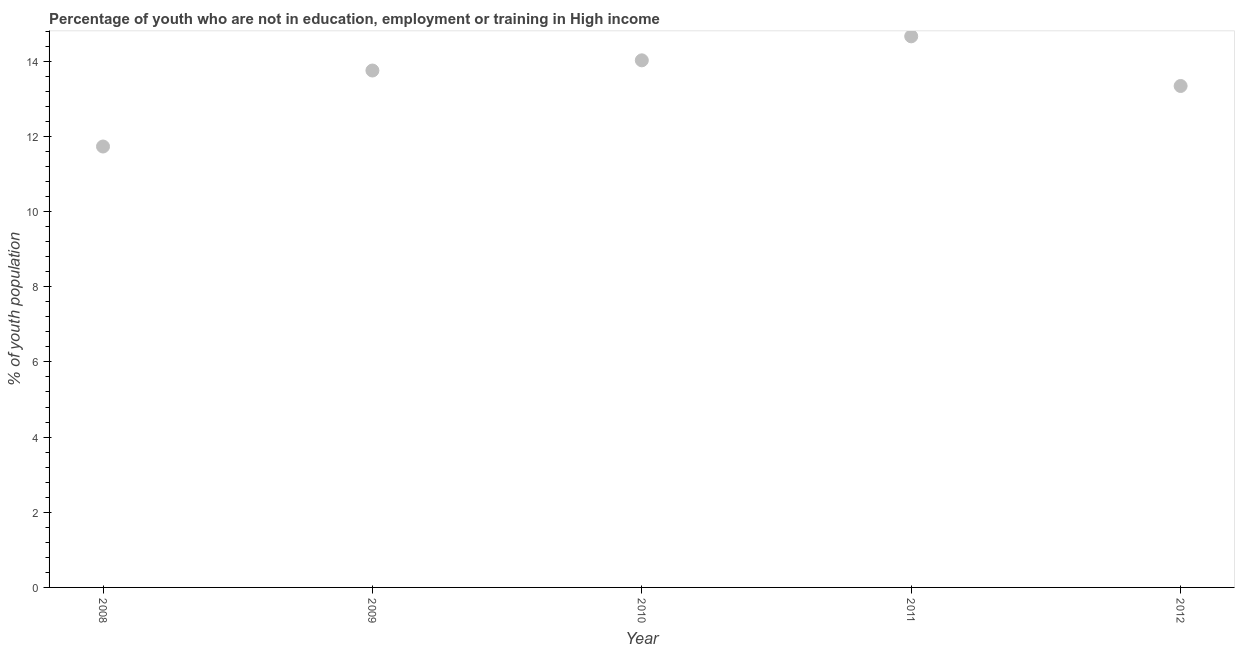What is the unemployed youth population in 2010?
Your answer should be compact. 14.02. Across all years, what is the maximum unemployed youth population?
Provide a short and direct response. 14.66. Across all years, what is the minimum unemployed youth population?
Offer a very short reply. 11.73. In which year was the unemployed youth population maximum?
Your answer should be very brief. 2011. In which year was the unemployed youth population minimum?
Offer a terse response. 2008. What is the sum of the unemployed youth population?
Ensure brevity in your answer.  67.51. What is the difference between the unemployed youth population in 2008 and 2009?
Offer a very short reply. -2.02. What is the average unemployed youth population per year?
Your answer should be compact. 13.5. What is the median unemployed youth population?
Provide a succinct answer. 13.75. What is the ratio of the unemployed youth population in 2009 to that in 2010?
Offer a very short reply. 0.98. Is the unemployed youth population in 2010 less than that in 2012?
Provide a short and direct response. No. What is the difference between the highest and the second highest unemployed youth population?
Ensure brevity in your answer.  0.64. Is the sum of the unemployed youth population in 2008 and 2012 greater than the maximum unemployed youth population across all years?
Your response must be concise. Yes. What is the difference between the highest and the lowest unemployed youth population?
Your answer should be very brief. 2.93. In how many years, is the unemployed youth population greater than the average unemployed youth population taken over all years?
Offer a very short reply. 3. Does the unemployed youth population monotonically increase over the years?
Give a very brief answer. No. How many years are there in the graph?
Keep it short and to the point. 5. Does the graph contain any zero values?
Your response must be concise. No. What is the title of the graph?
Provide a succinct answer. Percentage of youth who are not in education, employment or training in High income. What is the label or title of the X-axis?
Your response must be concise. Year. What is the label or title of the Y-axis?
Keep it short and to the point. % of youth population. What is the % of youth population in 2008?
Keep it short and to the point. 11.73. What is the % of youth population in 2009?
Your answer should be very brief. 13.75. What is the % of youth population in 2010?
Make the answer very short. 14.02. What is the % of youth population in 2011?
Ensure brevity in your answer.  14.66. What is the % of youth population in 2012?
Ensure brevity in your answer.  13.34. What is the difference between the % of youth population in 2008 and 2009?
Your answer should be compact. -2.02. What is the difference between the % of youth population in 2008 and 2010?
Keep it short and to the point. -2.29. What is the difference between the % of youth population in 2008 and 2011?
Provide a succinct answer. -2.93. What is the difference between the % of youth population in 2008 and 2012?
Offer a very short reply. -1.61. What is the difference between the % of youth population in 2009 and 2010?
Your answer should be compact. -0.27. What is the difference between the % of youth population in 2009 and 2011?
Your answer should be compact. -0.91. What is the difference between the % of youth population in 2009 and 2012?
Give a very brief answer. 0.41. What is the difference between the % of youth population in 2010 and 2011?
Keep it short and to the point. -0.64. What is the difference between the % of youth population in 2010 and 2012?
Make the answer very short. 0.68. What is the difference between the % of youth population in 2011 and 2012?
Ensure brevity in your answer.  1.32. What is the ratio of the % of youth population in 2008 to that in 2009?
Your response must be concise. 0.85. What is the ratio of the % of youth population in 2008 to that in 2010?
Provide a succinct answer. 0.84. What is the ratio of the % of youth population in 2008 to that in 2011?
Your answer should be compact. 0.8. What is the ratio of the % of youth population in 2008 to that in 2012?
Make the answer very short. 0.88. What is the ratio of the % of youth population in 2009 to that in 2010?
Your response must be concise. 0.98. What is the ratio of the % of youth population in 2009 to that in 2011?
Your answer should be compact. 0.94. What is the ratio of the % of youth population in 2009 to that in 2012?
Ensure brevity in your answer.  1.03. What is the ratio of the % of youth population in 2010 to that in 2011?
Provide a succinct answer. 0.96. What is the ratio of the % of youth population in 2010 to that in 2012?
Offer a very short reply. 1.05. What is the ratio of the % of youth population in 2011 to that in 2012?
Make the answer very short. 1.1. 